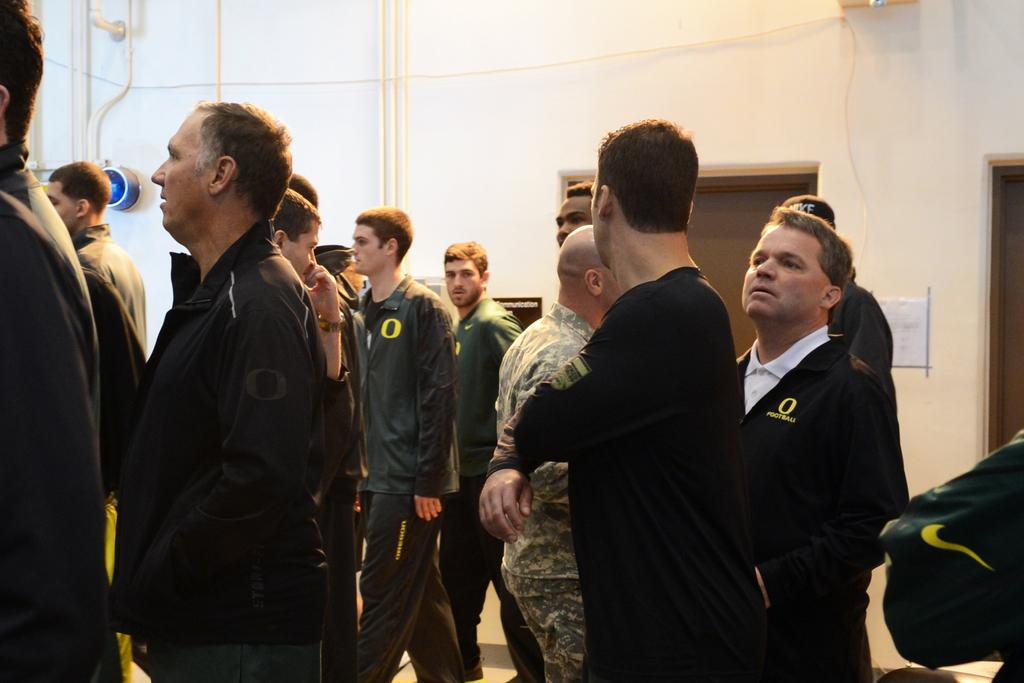What is the main subject of the image? There is a group of people standing in the center of the image. What can be seen in the background of the image? There is a wall, pipes, a light, a paper, and doors in the background of the image. Can you describe the wall in the background? The wall is a part of the background and does not have any specific details mentioned in the facts. What type of cough medicine is being discussed by the group of people in the image? There is no mention of cough medicine or any discussion in the image. 